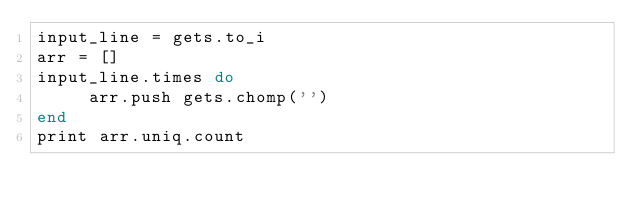Convert code to text. <code><loc_0><loc_0><loc_500><loc_500><_Ruby_>input_line = gets.to_i
arr = []
input_line.times do
     arr.push gets.chomp('')
end
print arr.uniq.count</code> 